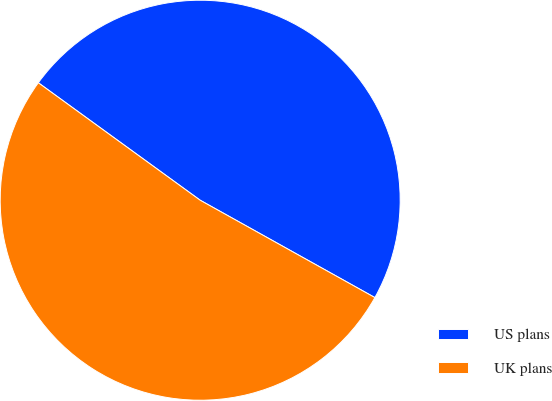Convert chart. <chart><loc_0><loc_0><loc_500><loc_500><pie_chart><fcel>US plans<fcel>UK plans<nl><fcel>48.1%<fcel>51.9%<nl></chart> 